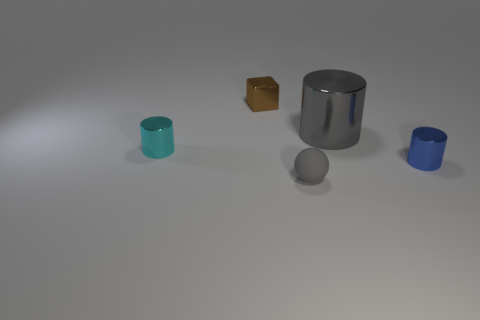How many tiny blue objects are behind the gray object that is behind the cylinder that is to the left of the brown metallic thing?
Ensure brevity in your answer.  0. There is a small sphere that is the same color as the big shiny cylinder; what is it made of?
Keep it short and to the point. Rubber. Are there more tiny cyan metallic blocks than cyan things?
Keep it short and to the point. No. Does the cyan cylinder have the same size as the gray cylinder?
Provide a succinct answer. No. How many objects are tiny cyan things or big blue matte cubes?
Your answer should be very brief. 1. What shape is the gray object that is behind the metallic object right of the large metallic cylinder right of the brown metal cube?
Provide a succinct answer. Cylinder. Is the material of the cylinder left of the small shiny cube the same as the gray thing that is to the right of the gray rubber sphere?
Your answer should be very brief. Yes. What is the material of the other small object that is the same shape as the tiny cyan object?
Make the answer very short. Metal. Is there any other thing that is the same size as the gray metal object?
Offer a very short reply. No. There is a gray thing that is behind the tiny gray rubber sphere; does it have the same shape as the tiny metal thing that is on the right side of the gray sphere?
Make the answer very short. Yes. 